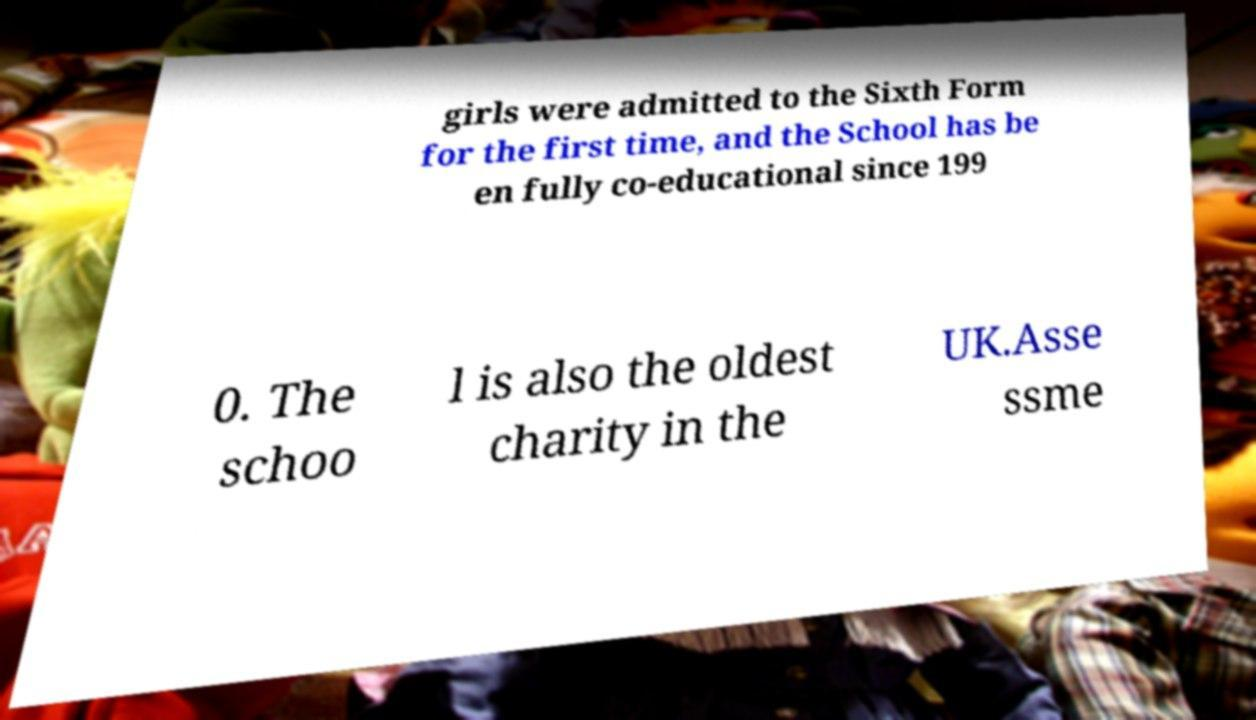Please identify and transcribe the text found in this image. girls were admitted to the Sixth Form for the first time, and the School has be en fully co-educational since 199 0. The schoo l is also the oldest charity in the UK.Asse ssme 